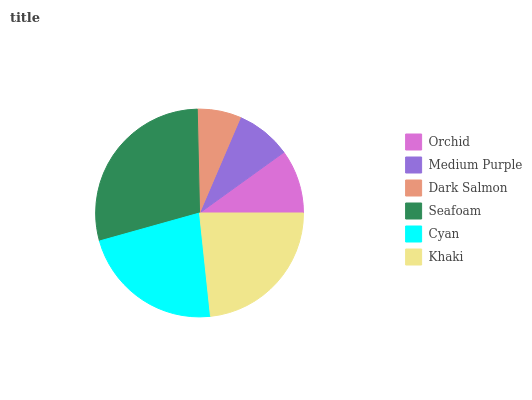Is Dark Salmon the minimum?
Answer yes or no. Yes. Is Seafoam the maximum?
Answer yes or no. Yes. Is Medium Purple the minimum?
Answer yes or no. No. Is Medium Purple the maximum?
Answer yes or no. No. Is Orchid greater than Medium Purple?
Answer yes or no. Yes. Is Medium Purple less than Orchid?
Answer yes or no. Yes. Is Medium Purple greater than Orchid?
Answer yes or no. No. Is Orchid less than Medium Purple?
Answer yes or no. No. Is Cyan the high median?
Answer yes or no. Yes. Is Orchid the low median?
Answer yes or no. Yes. Is Khaki the high median?
Answer yes or no. No. Is Seafoam the low median?
Answer yes or no. No. 